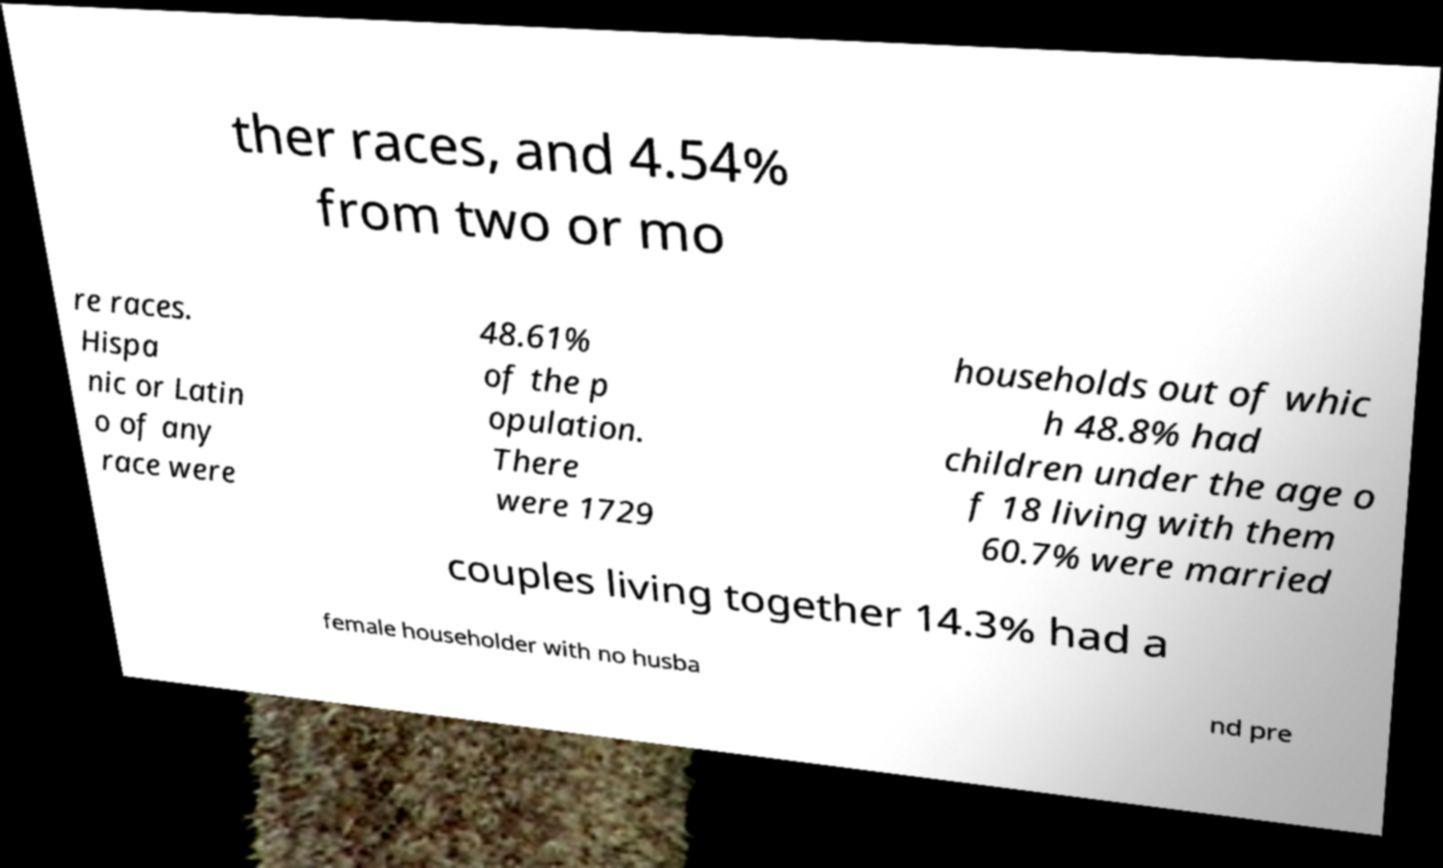Could you assist in decoding the text presented in this image and type it out clearly? ther races, and 4.54% from two or mo re races. Hispa nic or Latin o of any race were 48.61% of the p opulation. There were 1729 households out of whic h 48.8% had children under the age o f 18 living with them 60.7% were married couples living together 14.3% had a female householder with no husba nd pre 